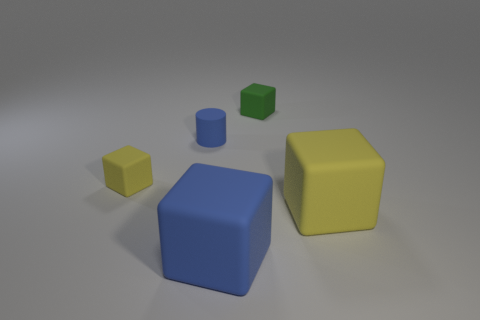Do the blue cylinder and the blue rubber block have the same size?
Your response must be concise. No. Is the shape of the green matte thing on the right side of the tiny yellow matte block the same as  the small yellow rubber thing?
Offer a terse response. Yes. What number of objects are either rubber cubes that are left of the green block or big yellow rubber things?
Offer a terse response. 3. What color is the other small object that is the same shape as the tiny green thing?
Your answer should be compact. Yellow. There is a yellow rubber block that is on the right side of the large blue cube; what size is it?
Ensure brevity in your answer.  Large. Is the color of the small rubber cylinder the same as the large rubber object that is to the left of the tiny green thing?
Provide a succinct answer. Yes. How many other objects are there of the same material as the cylinder?
Provide a succinct answer. 4. Is the number of green objects greater than the number of things?
Keep it short and to the point. No. There is a big rubber object that is on the left side of the tiny green block; is its color the same as the small rubber cylinder?
Your response must be concise. Yes. There is a large matte thing on the right side of the small green matte thing; are there any rubber objects behind it?
Offer a terse response. Yes. 